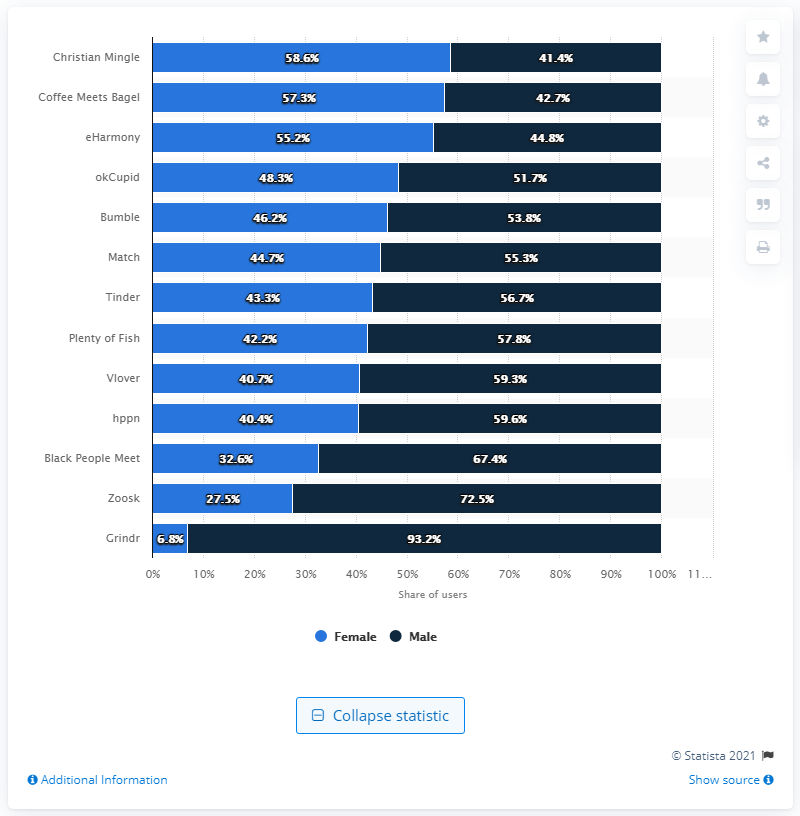Mention a couple of crucial points in this snapshot. According to a study, 56.7% of Tinder users were male. It is a fact that Grindr is primarily used by males. Grindr, a popular gay dating app, has the least number of users among all gender options, including Female. 